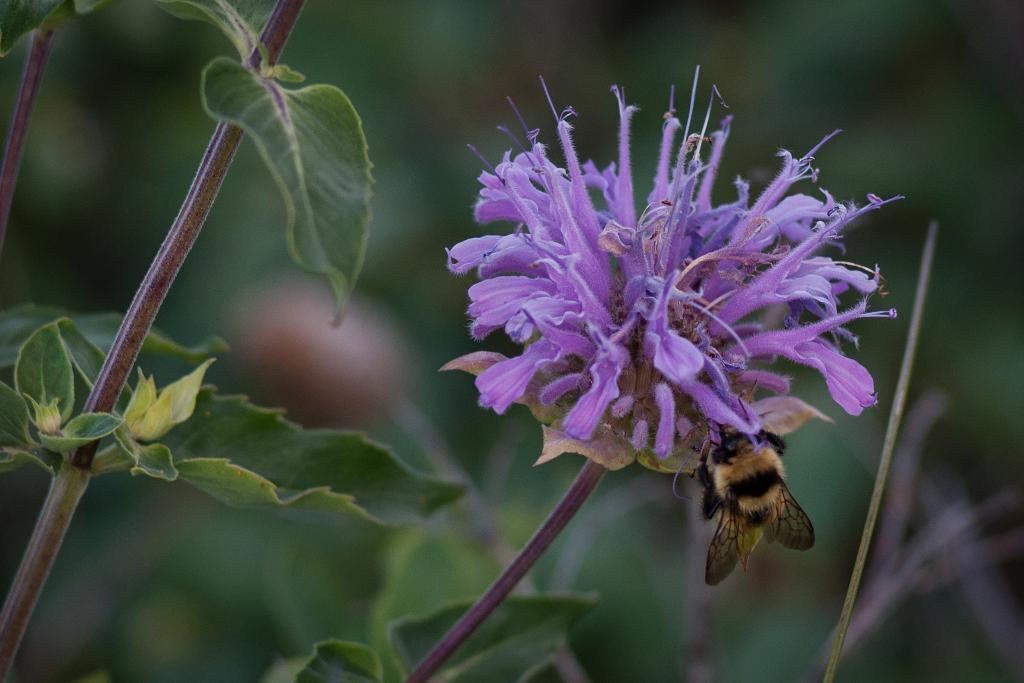What is the main subject of the image? The main subject of the image is a honey bee on a flower. Can you describe the flower color be identified in the image? Yes, the flower has a brinjal color. What else can be seen on the left side of the image? There is a plant on the left side of the image. Is there a spy observing the honey bee in the image? There is no indication of a spy or any human presence in the image; it primarily features a honey bee on a flower. What type of clover is present in the image? There is no clover present in the image; the flower mentioned is brinjal-colored. 